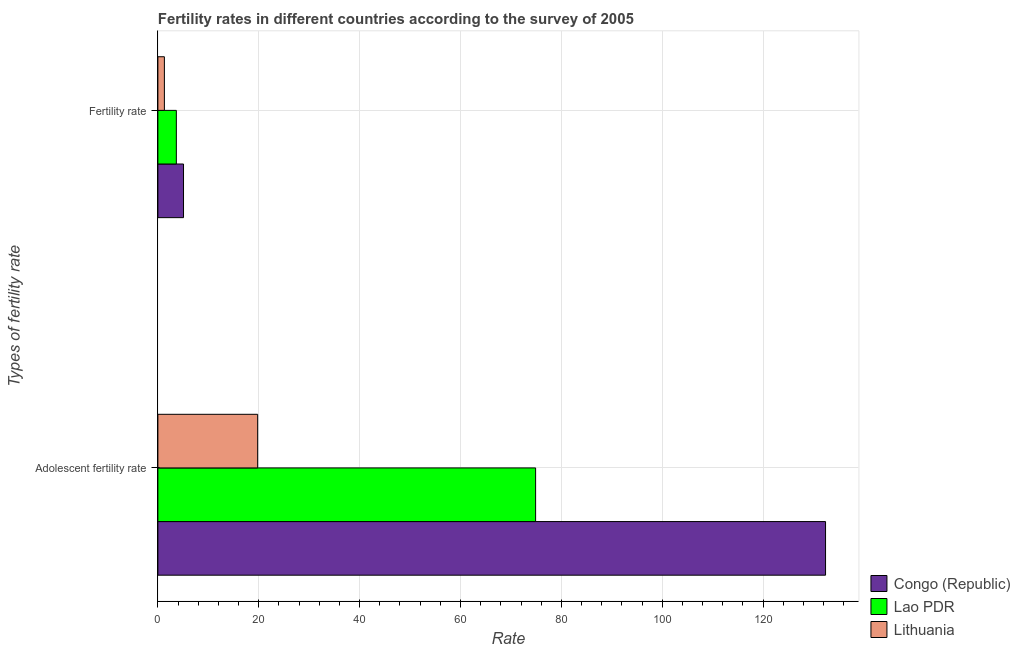How many different coloured bars are there?
Keep it short and to the point. 3. Are the number of bars per tick equal to the number of legend labels?
Offer a very short reply. Yes. Are the number of bars on each tick of the Y-axis equal?
Your answer should be compact. Yes. What is the label of the 1st group of bars from the top?
Offer a terse response. Fertility rate. What is the adolescent fertility rate in Lao PDR?
Your answer should be very brief. 74.89. Across all countries, what is the maximum fertility rate?
Offer a terse response. 5.08. Across all countries, what is the minimum adolescent fertility rate?
Your response must be concise. 19.78. In which country was the adolescent fertility rate maximum?
Give a very brief answer. Congo (Republic). In which country was the adolescent fertility rate minimum?
Provide a short and direct response. Lithuania. What is the total fertility rate in the graph?
Keep it short and to the point. 10.03. What is the difference between the fertility rate in Lithuania and that in Lao PDR?
Your answer should be compact. -2.37. What is the difference between the adolescent fertility rate in Lao PDR and the fertility rate in Lithuania?
Ensure brevity in your answer.  73.6. What is the average adolescent fertility rate per country?
Ensure brevity in your answer.  75.69. What is the difference between the adolescent fertility rate and fertility rate in Lao PDR?
Give a very brief answer. 71.23. What is the ratio of the adolescent fertility rate in Lithuania to that in Congo (Republic)?
Provide a succinct answer. 0.15. What does the 1st bar from the top in Fertility rate represents?
Provide a short and direct response. Lithuania. What does the 3rd bar from the bottom in Adolescent fertility rate represents?
Make the answer very short. Lithuania. How many countries are there in the graph?
Keep it short and to the point. 3. What is the difference between two consecutive major ticks on the X-axis?
Give a very brief answer. 20. Are the values on the major ticks of X-axis written in scientific E-notation?
Provide a short and direct response. No. Does the graph contain grids?
Keep it short and to the point. Yes. Where does the legend appear in the graph?
Ensure brevity in your answer.  Bottom right. How are the legend labels stacked?
Offer a terse response. Vertical. What is the title of the graph?
Make the answer very short. Fertility rates in different countries according to the survey of 2005. Does "Philippines" appear as one of the legend labels in the graph?
Offer a terse response. No. What is the label or title of the X-axis?
Ensure brevity in your answer.  Rate. What is the label or title of the Y-axis?
Make the answer very short. Types of fertility rate. What is the Rate in Congo (Republic) in Adolescent fertility rate?
Provide a short and direct response. 132.38. What is the Rate of Lao PDR in Adolescent fertility rate?
Your answer should be compact. 74.89. What is the Rate of Lithuania in Adolescent fertility rate?
Offer a very short reply. 19.78. What is the Rate in Congo (Republic) in Fertility rate?
Offer a terse response. 5.08. What is the Rate in Lao PDR in Fertility rate?
Offer a terse response. 3.66. What is the Rate of Lithuania in Fertility rate?
Offer a very short reply. 1.29. Across all Types of fertility rate, what is the maximum Rate of Congo (Republic)?
Offer a very short reply. 132.38. Across all Types of fertility rate, what is the maximum Rate of Lao PDR?
Your response must be concise. 74.89. Across all Types of fertility rate, what is the maximum Rate in Lithuania?
Provide a succinct answer. 19.78. Across all Types of fertility rate, what is the minimum Rate of Congo (Republic)?
Keep it short and to the point. 5.08. Across all Types of fertility rate, what is the minimum Rate of Lao PDR?
Ensure brevity in your answer.  3.66. Across all Types of fertility rate, what is the minimum Rate of Lithuania?
Your answer should be compact. 1.29. What is the total Rate in Congo (Republic) in the graph?
Your response must be concise. 137.46. What is the total Rate of Lao PDR in the graph?
Your answer should be very brief. 78.55. What is the total Rate of Lithuania in the graph?
Offer a very short reply. 21.07. What is the difference between the Rate of Congo (Republic) in Adolescent fertility rate and that in Fertility rate?
Offer a terse response. 127.3. What is the difference between the Rate of Lao PDR in Adolescent fertility rate and that in Fertility rate?
Keep it short and to the point. 71.23. What is the difference between the Rate in Lithuania in Adolescent fertility rate and that in Fertility rate?
Your answer should be compact. 18.49. What is the difference between the Rate in Congo (Republic) in Adolescent fertility rate and the Rate in Lao PDR in Fertility rate?
Give a very brief answer. 128.72. What is the difference between the Rate in Congo (Republic) in Adolescent fertility rate and the Rate in Lithuania in Fertility rate?
Your response must be concise. 131.09. What is the difference between the Rate of Lao PDR in Adolescent fertility rate and the Rate of Lithuania in Fertility rate?
Keep it short and to the point. 73.6. What is the average Rate in Congo (Republic) per Types of fertility rate?
Provide a short and direct response. 68.73. What is the average Rate in Lao PDR per Types of fertility rate?
Ensure brevity in your answer.  39.28. What is the average Rate of Lithuania per Types of fertility rate?
Offer a terse response. 10.54. What is the difference between the Rate in Congo (Republic) and Rate in Lao PDR in Adolescent fertility rate?
Your response must be concise. 57.49. What is the difference between the Rate in Congo (Republic) and Rate in Lithuania in Adolescent fertility rate?
Provide a short and direct response. 112.6. What is the difference between the Rate of Lao PDR and Rate of Lithuania in Adolescent fertility rate?
Ensure brevity in your answer.  55.11. What is the difference between the Rate of Congo (Republic) and Rate of Lao PDR in Fertility rate?
Give a very brief answer. 1.42. What is the difference between the Rate of Congo (Republic) and Rate of Lithuania in Fertility rate?
Give a very brief answer. 3.79. What is the difference between the Rate in Lao PDR and Rate in Lithuania in Fertility rate?
Your response must be concise. 2.37. What is the ratio of the Rate of Congo (Republic) in Adolescent fertility rate to that in Fertility rate?
Provide a short and direct response. 26.05. What is the ratio of the Rate in Lao PDR in Adolescent fertility rate to that in Fertility rate?
Your response must be concise. 20.46. What is the ratio of the Rate in Lithuania in Adolescent fertility rate to that in Fertility rate?
Give a very brief answer. 15.33. What is the difference between the highest and the second highest Rate of Congo (Republic)?
Your response must be concise. 127.3. What is the difference between the highest and the second highest Rate in Lao PDR?
Ensure brevity in your answer.  71.23. What is the difference between the highest and the second highest Rate of Lithuania?
Provide a succinct answer. 18.49. What is the difference between the highest and the lowest Rate in Congo (Republic)?
Provide a short and direct response. 127.3. What is the difference between the highest and the lowest Rate in Lao PDR?
Make the answer very short. 71.23. What is the difference between the highest and the lowest Rate of Lithuania?
Keep it short and to the point. 18.49. 